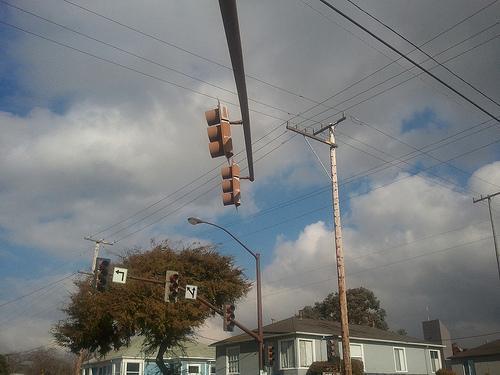How many traffic lights are there?
Give a very brief answer. 7. How many streetlights are there?
Give a very brief answer. 1. 